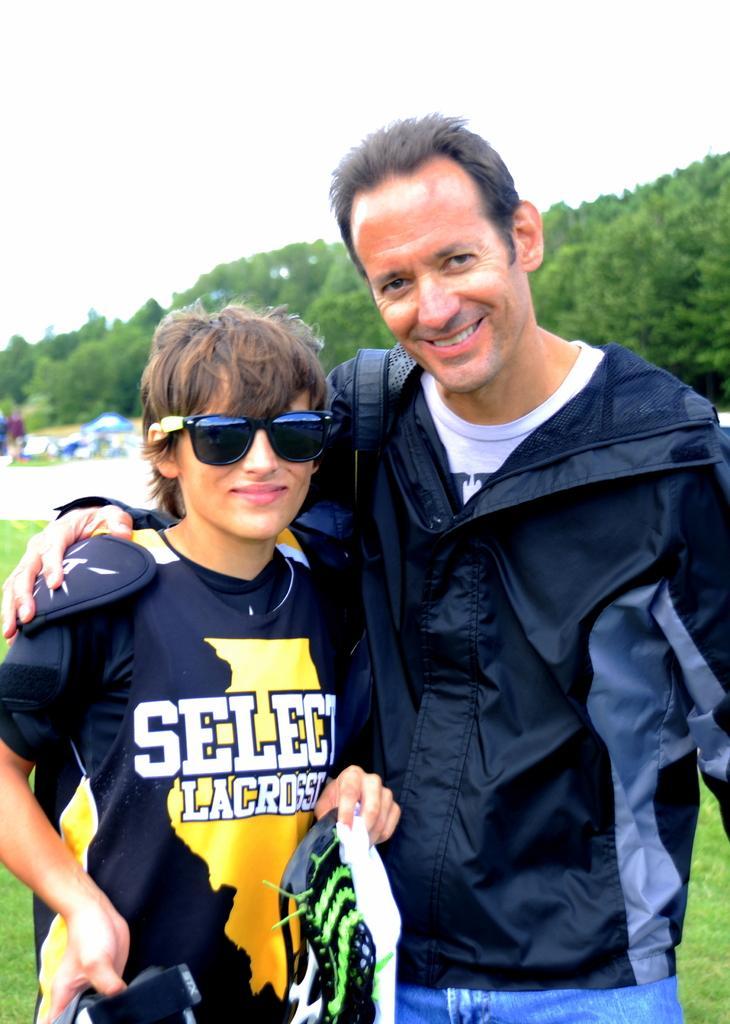Can you describe this image briefly? In this image there are two persons in the middle. The man on the right side has kept his hand on the person who is beside him. In the background there are trees. At the top there is sky. On the ground there is grass. 